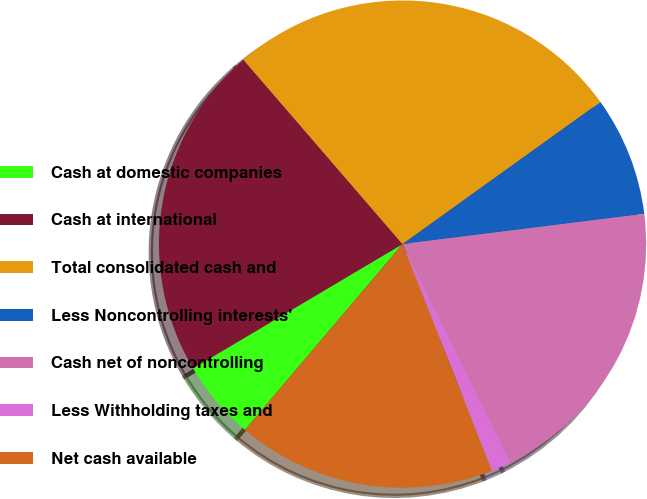Convert chart to OTSL. <chart><loc_0><loc_0><loc_500><loc_500><pie_chart><fcel>Cash at domestic companies<fcel>Cash at international<fcel>Total consolidated cash and<fcel>Less Noncontrolling interests'<fcel>Cash net of noncontrolling<fcel>Less Withholding taxes and<fcel>Net cash available<nl><fcel>5.28%<fcel>22.19%<fcel>26.42%<fcel>7.93%<fcel>19.68%<fcel>1.32%<fcel>17.17%<nl></chart> 